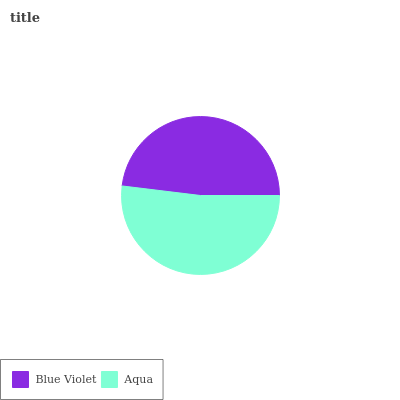Is Blue Violet the minimum?
Answer yes or no. Yes. Is Aqua the maximum?
Answer yes or no. Yes. Is Aqua the minimum?
Answer yes or no. No. Is Aqua greater than Blue Violet?
Answer yes or no. Yes. Is Blue Violet less than Aqua?
Answer yes or no. Yes. Is Blue Violet greater than Aqua?
Answer yes or no. No. Is Aqua less than Blue Violet?
Answer yes or no. No. Is Aqua the high median?
Answer yes or no. Yes. Is Blue Violet the low median?
Answer yes or no. Yes. Is Blue Violet the high median?
Answer yes or no. No. Is Aqua the low median?
Answer yes or no. No. 